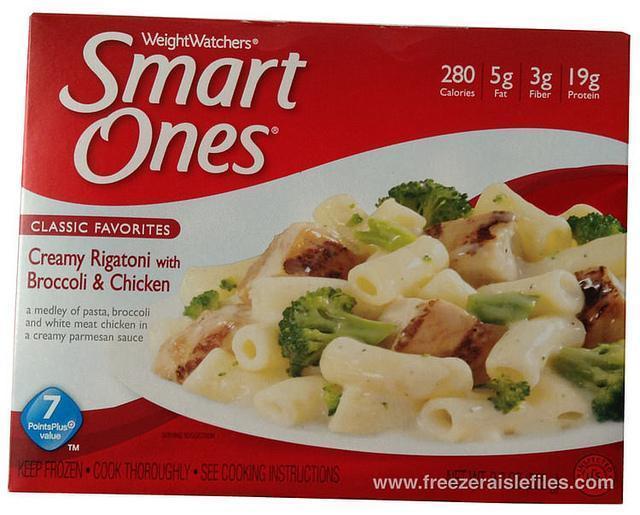How many broccolis are there?
Give a very brief answer. 4. 